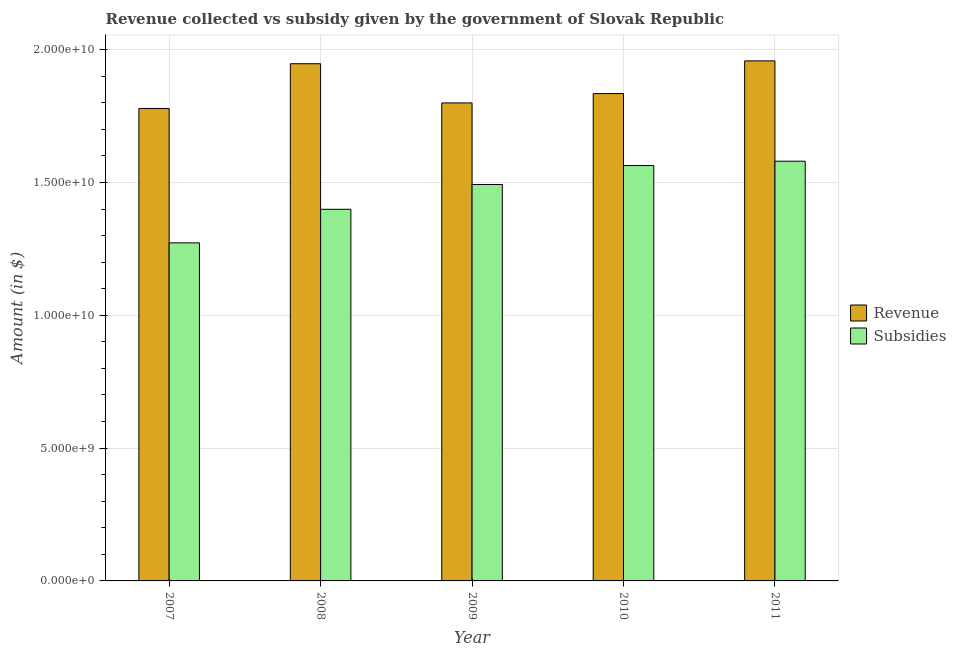How many groups of bars are there?
Offer a very short reply. 5. Are the number of bars on each tick of the X-axis equal?
Offer a very short reply. Yes. How many bars are there on the 5th tick from the right?
Give a very brief answer. 2. In how many cases, is the number of bars for a given year not equal to the number of legend labels?
Offer a terse response. 0. What is the amount of subsidies given in 2009?
Ensure brevity in your answer.  1.49e+1. Across all years, what is the maximum amount of revenue collected?
Give a very brief answer. 1.96e+1. Across all years, what is the minimum amount of revenue collected?
Your response must be concise. 1.78e+1. What is the total amount of subsidies given in the graph?
Your response must be concise. 7.31e+1. What is the difference between the amount of revenue collected in 2009 and that in 2011?
Keep it short and to the point. -1.58e+09. What is the difference between the amount of subsidies given in 2011 and the amount of revenue collected in 2010?
Keep it short and to the point. 1.63e+08. What is the average amount of revenue collected per year?
Your answer should be very brief. 1.86e+1. In how many years, is the amount of revenue collected greater than 14000000000 $?
Give a very brief answer. 5. What is the ratio of the amount of subsidies given in 2009 to that in 2010?
Keep it short and to the point. 0.95. Is the amount of subsidies given in 2009 less than that in 2011?
Provide a short and direct response. Yes. Is the difference between the amount of subsidies given in 2009 and 2010 greater than the difference between the amount of revenue collected in 2009 and 2010?
Keep it short and to the point. No. What is the difference between the highest and the second highest amount of revenue collected?
Make the answer very short. 1.07e+08. What is the difference between the highest and the lowest amount of revenue collected?
Offer a very short reply. 1.79e+09. In how many years, is the amount of revenue collected greater than the average amount of revenue collected taken over all years?
Provide a short and direct response. 2. Is the sum of the amount of revenue collected in 2008 and 2009 greater than the maximum amount of subsidies given across all years?
Give a very brief answer. Yes. What does the 2nd bar from the left in 2009 represents?
Give a very brief answer. Subsidies. What does the 1st bar from the right in 2011 represents?
Make the answer very short. Subsidies. How many bars are there?
Offer a very short reply. 10. Are all the bars in the graph horizontal?
Your answer should be compact. No. Are the values on the major ticks of Y-axis written in scientific E-notation?
Ensure brevity in your answer.  Yes. How many legend labels are there?
Keep it short and to the point. 2. What is the title of the graph?
Make the answer very short. Revenue collected vs subsidy given by the government of Slovak Republic. What is the label or title of the X-axis?
Ensure brevity in your answer.  Year. What is the label or title of the Y-axis?
Offer a very short reply. Amount (in $). What is the Amount (in $) of Revenue in 2007?
Give a very brief answer. 1.78e+1. What is the Amount (in $) in Subsidies in 2007?
Make the answer very short. 1.27e+1. What is the Amount (in $) in Revenue in 2008?
Offer a terse response. 1.95e+1. What is the Amount (in $) in Subsidies in 2008?
Your answer should be compact. 1.40e+1. What is the Amount (in $) of Revenue in 2009?
Provide a short and direct response. 1.80e+1. What is the Amount (in $) of Subsidies in 2009?
Provide a succinct answer. 1.49e+1. What is the Amount (in $) of Revenue in 2010?
Your response must be concise. 1.83e+1. What is the Amount (in $) in Subsidies in 2010?
Your answer should be compact. 1.56e+1. What is the Amount (in $) of Revenue in 2011?
Offer a very short reply. 1.96e+1. What is the Amount (in $) of Subsidies in 2011?
Make the answer very short. 1.58e+1. Across all years, what is the maximum Amount (in $) of Revenue?
Give a very brief answer. 1.96e+1. Across all years, what is the maximum Amount (in $) in Subsidies?
Your response must be concise. 1.58e+1. Across all years, what is the minimum Amount (in $) of Revenue?
Your answer should be very brief. 1.78e+1. Across all years, what is the minimum Amount (in $) in Subsidies?
Your response must be concise. 1.27e+1. What is the total Amount (in $) of Revenue in the graph?
Make the answer very short. 9.32e+1. What is the total Amount (in $) of Subsidies in the graph?
Provide a succinct answer. 7.31e+1. What is the difference between the Amount (in $) of Revenue in 2007 and that in 2008?
Keep it short and to the point. -1.69e+09. What is the difference between the Amount (in $) of Subsidies in 2007 and that in 2008?
Your response must be concise. -1.26e+09. What is the difference between the Amount (in $) of Revenue in 2007 and that in 2009?
Offer a very short reply. -2.09e+08. What is the difference between the Amount (in $) of Subsidies in 2007 and that in 2009?
Your response must be concise. -2.20e+09. What is the difference between the Amount (in $) in Revenue in 2007 and that in 2010?
Your answer should be very brief. -5.61e+08. What is the difference between the Amount (in $) of Subsidies in 2007 and that in 2010?
Keep it short and to the point. -2.91e+09. What is the difference between the Amount (in $) of Revenue in 2007 and that in 2011?
Give a very brief answer. -1.79e+09. What is the difference between the Amount (in $) in Subsidies in 2007 and that in 2011?
Provide a succinct answer. -3.07e+09. What is the difference between the Amount (in $) of Revenue in 2008 and that in 2009?
Your answer should be compact. 1.48e+09. What is the difference between the Amount (in $) in Subsidies in 2008 and that in 2009?
Make the answer very short. -9.33e+08. What is the difference between the Amount (in $) in Revenue in 2008 and that in 2010?
Make the answer very short. 1.12e+09. What is the difference between the Amount (in $) in Subsidies in 2008 and that in 2010?
Your response must be concise. -1.65e+09. What is the difference between the Amount (in $) in Revenue in 2008 and that in 2011?
Your answer should be compact. -1.07e+08. What is the difference between the Amount (in $) of Subsidies in 2008 and that in 2011?
Ensure brevity in your answer.  -1.81e+09. What is the difference between the Amount (in $) in Revenue in 2009 and that in 2010?
Ensure brevity in your answer.  -3.52e+08. What is the difference between the Amount (in $) of Subsidies in 2009 and that in 2010?
Ensure brevity in your answer.  -7.15e+08. What is the difference between the Amount (in $) in Revenue in 2009 and that in 2011?
Your answer should be compact. -1.58e+09. What is the difference between the Amount (in $) of Subsidies in 2009 and that in 2011?
Ensure brevity in your answer.  -8.77e+08. What is the difference between the Amount (in $) in Revenue in 2010 and that in 2011?
Provide a succinct answer. -1.23e+09. What is the difference between the Amount (in $) in Subsidies in 2010 and that in 2011?
Offer a very short reply. -1.63e+08. What is the difference between the Amount (in $) of Revenue in 2007 and the Amount (in $) of Subsidies in 2008?
Your answer should be compact. 3.80e+09. What is the difference between the Amount (in $) of Revenue in 2007 and the Amount (in $) of Subsidies in 2009?
Provide a succinct answer. 2.86e+09. What is the difference between the Amount (in $) in Revenue in 2007 and the Amount (in $) in Subsidies in 2010?
Your answer should be very brief. 2.15e+09. What is the difference between the Amount (in $) of Revenue in 2007 and the Amount (in $) of Subsidies in 2011?
Provide a short and direct response. 1.98e+09. What is the difference between the Amount (in $) in Revenue in 2008 and the Amount (in $) in Subsidies in 2009?
Make the answer very short. 4.55e+09. What is the difference between the Amount (in $) in Revenue in 2008 and the Amount (in $) in Subsidies in 2010?
Make the answer very short. 3.83e+09. What is the difference between the Amount (in $) in Revenue in 2008 and the Amount (in $) in Subsidies in 2011?
Offer a terse response. 3.67e+09. What is the difference between the Amount (in $) of Revenue in 2009 and the Amount (in $) of Subsidies in 2010?
Keep it short and to the point. 2.36e+09. What is the difference between the Amount (in $) of Revenue in 2009 and the Amount (in $) of Subsidies in 2011?
Offer a terse response. 2.19e+09. What is the difference between the Amount (in $) of Revenue in 2010 and the Amount (in $) of Subsidies in 2011?
Keep it short and to the point. 2.55e+09. What is the average Amount (in $) in Revenue per year?
Give a very brief answer. 1.86e+1. What is the average Amount (in $) in Subsidies per year?
Provide a succinct answer. 1.46e+1. In the year 2007, what is the difference between the Amount (in $) in Revenue and Amount (in $) in Subsidies?
Your response must be concise. 5.06e+09. In the year 2008, what is the difference between the Amount (in $) of Revenue and Amount (in $) of Subsidies?
Keep it short and to the point. 5.48e+09. In the year 2009, what is the difference between the Amount (in $) of Revenue and Amount (in $) of Subsidies?
Your answer should be compact. 3.07e+09. In the year 2010, what is the difference between the Amount (in $) in Revenue and Amount (in $) in Subsidies?
Provide a succinct answer. 2.71e+09. In the year 2011, what is the difference between the Amount (in $) of Revenue and Amount (in $) of Subsidies?
Keep it short and to the point. 3.78e+09. What is the ratio of the Amount (in $) of Revenue in 2007 to that in 2008?
Offer a terse response. 0.91. What is the ratio of the Amount (in $) in Subsidies in 2007 to that in 2008?
Provide a short and direct response. 0.91. What is the ratio of the Amount (in $) in Revenue in 2007 to that in 2009?
Offer a terse response. 0.99. What is the ratio of the Amount (in $) of Subsidies in 2007 to that in 2009?
Ensure brevity in your answer.  0.85. What is the ratio of the Amount (in $) of Revenue in 2007 to that in 2010?
Offer a very short reply. 0.97. What is the ratio of the Amount (in $) in Subsidies in 2007 to that in 2010?
Keep it short and to the point. 0.81. What is the ratio of the Amount (in $) in Revenue in 2007 to that in 2011?
Give a very brief answer. 0.91. What is the ratio of the Amount (in $) of Subsidies in 2007 to that in 2011?
Provide a short and direct response. 0.81. What is the ratio of the Amount (in $) of Revenue in 2008 to that in 2009?
Ensure brevity in your answer.  1.08. What is the ratio of the Amount (in $) of Subsidies in 2008 to that in 2009?
Make the answer very short. 0.94. What is the ratio of the Amount (in $) in Revenue in 2008 to that in 2010?
Make the answer very short. 1.06. What is the ratio of the Amount (in $) of Subsidies in 2008 to that in 2010?
Give a very brief answer. 0.89. What is the ratio of the Amount (in $) of Subsidies in 2008 to that in 2011?
Your answer should be compact. 0.89. What is the ratio of the Amount (in $) of Revenue in 2009 to that in 2010?
Your answer should be very brief. 0.98. What is the ratio of the Amount (in $) in Subsidies in 2009 to that in 2010?
Make the answer very short. 0.95. What is the ratio of the Amount (in $) in Revenue in 2009 to that in 2011?
Your response must be concise. 0.92. What is the ratio of the Amount (in $) in Subsidies in 2009 to that in 2011?
Provide a succinct answer. 0.94. What is the ratio of the Amount (in $) of Revenue in 2010 to that in 2011?
Your response must be concise. 0.94. What is the ratio of the Amount (in $) of Subsidies in 2010 to that in 2011?
Make the answer very short. 0.99. What is the difference between the highest and the second highest Amount (in $) of Revenue?
Offer a very short reply. 1.07e+08. What is the difference between the highest and the second highest Amount (in $) of Subsidies?
Provide a short and direct response. 1.63e+08. What is the difference between the highest and the lowest Amount (in $) of Revenue?
Offer a very short reply. 1.79e+09. What is the difference between the highest and the lowest Amount (in $) of Subsidies?
Give a very brief answer. 3.07e+09. 